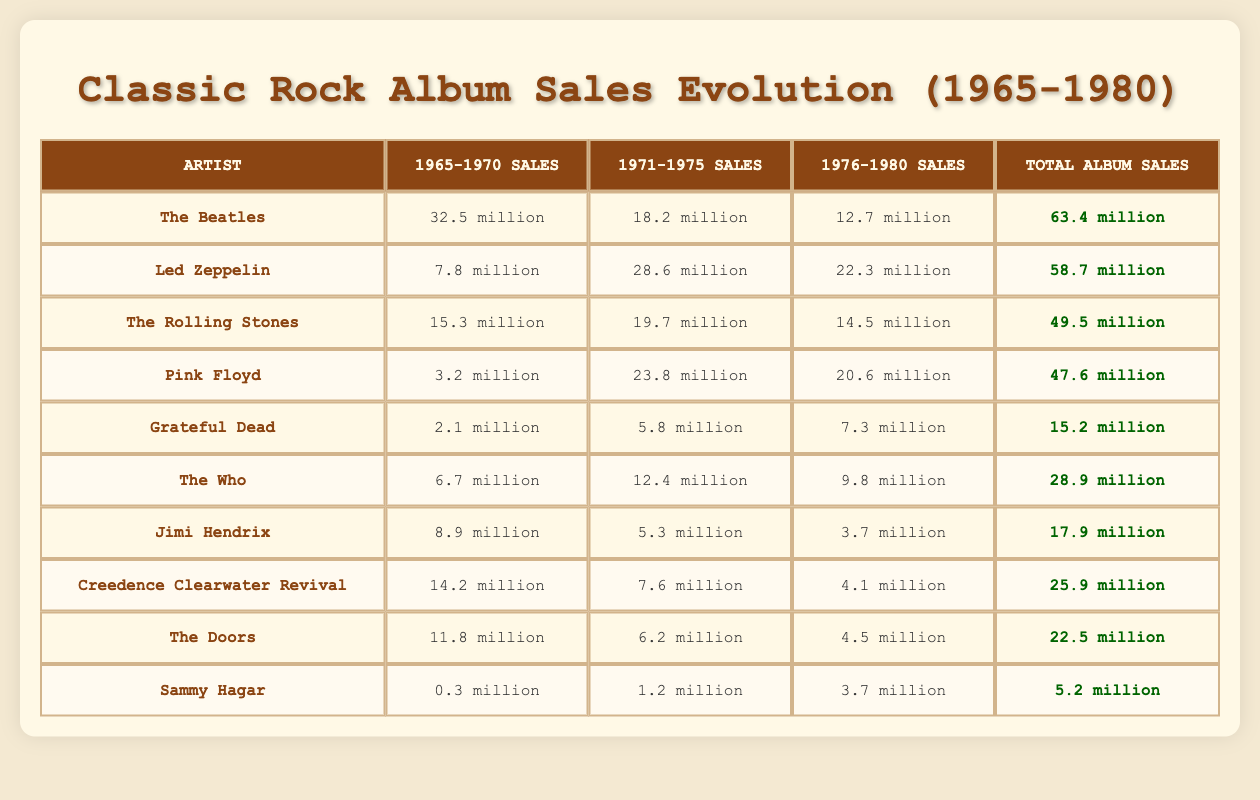What are the total album sales for The Beatles? The table shows that The Beatles have "63.4 million" for Total Album Sales.
Answer: 63.4 million Which artist had the highest sales from 1971 to 1975? In the table, Led Zeppelin shows the highest sales with "28.6 million" from the 1971-1975 period.
Answer: Led Zeppelin What is the difference in total album sales between The Rolling Stones and Pink Floyd? The Rolling Stones have "49.5 million" total sales while Pink Floyd has "47.6 million". The difference is 49.5 million - 47.6 million = 1.9 million.
Answer: 1.9 million Did Grateful Dead's album sales increase in the 1970s compared to the 1965-1970 period? Grateful Dead sold "2.1 million" in the early period and "5.8 million" in the 1971-1975 period, showing an increase. The sales in 1976-1980 were also higher at "7.3 million", thus confirming the increase.
Answer: Yes What was the total album sales for Creedence Clearwater Revival from 1971-1980? The table lists "7.6 million" for 1971-1975 and "4.1 million" for 1976-1980, which sums to 7.6 million + 4.1 million = 11.7 million.
Answer: 11.7 million Which artist has the lowest total album sales? The table indicates that Sammy Hagar has "5.2 million," which is the lowest among all artists listed.
Answer: Sammy Hagar How much did Jimi Hendrix sell in total from 1965 to 1980? Jimi Hendrix has "17.9 million" as listed in the Total Album Sales section of the table.
Answer: 17.9 million What percentage of total sales did The Who achieve compared to The Beatles? The Who has "28.9 million" and The Beatles have "63.4 million". The percentage calculation is (28.9 million / 63.4 million) * 100 = approximately 45.6%.
Answer: 45.6% 